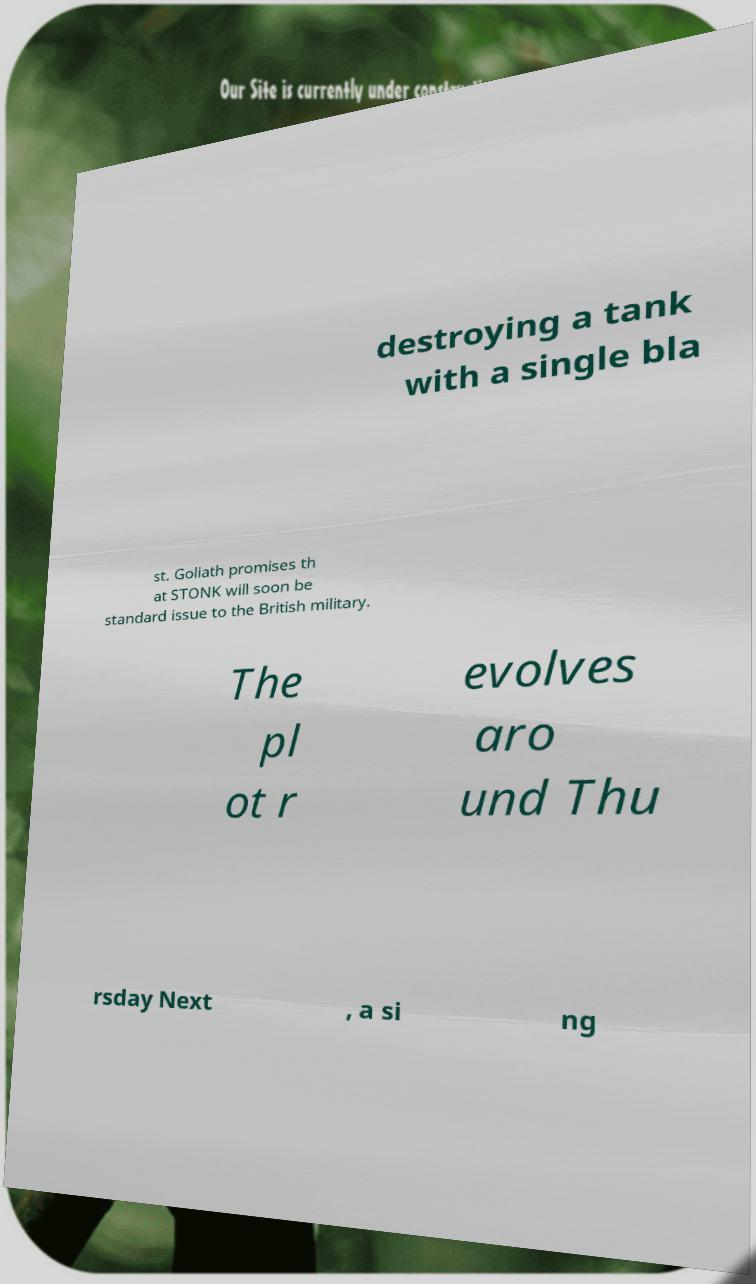Can you read and provide the text displayed in the image?This photo seems to have some interesting text. Can you extract and type it out for me? destroying a tank with a single bla st. Goliath promises th at STONK will soon be standard issue to the British military. The pl ot r evolves aro und Thu rsday Next , a si ng 